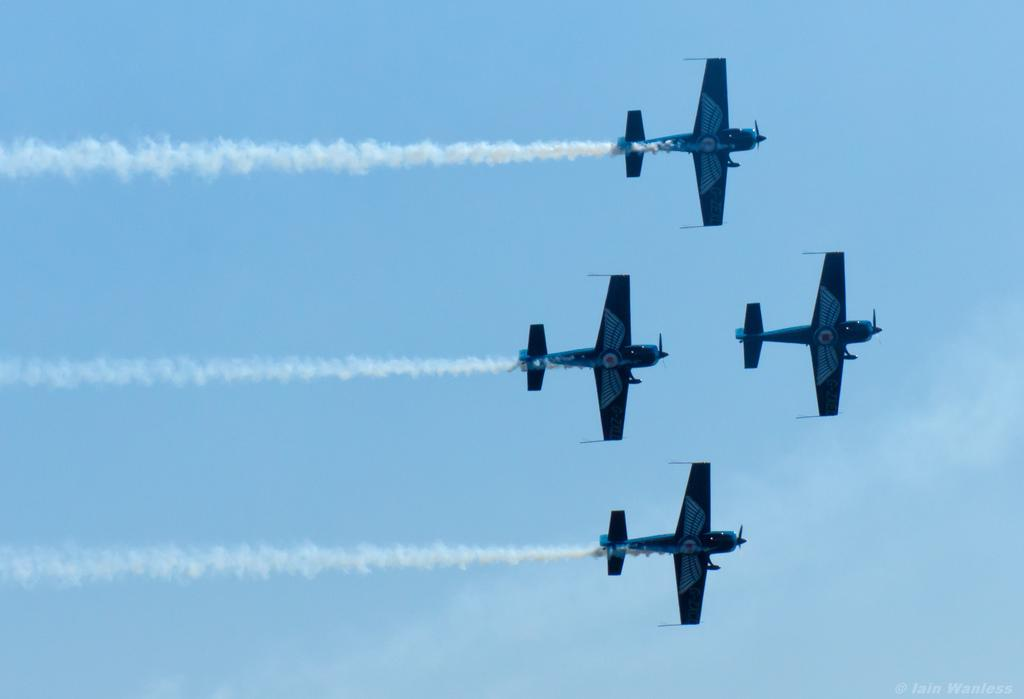What is the main subject of the image? The main subject of the image is airplanes. What are the airplanes doing in the image? The airplanes are flying in the image. What can be seen in the background of the image? The sky is visible in the background of the image. What type of kitty can be seen playing with the bushes in the image? There is no kitty or bushes present in the image; it features airplanes flying in the sky. 